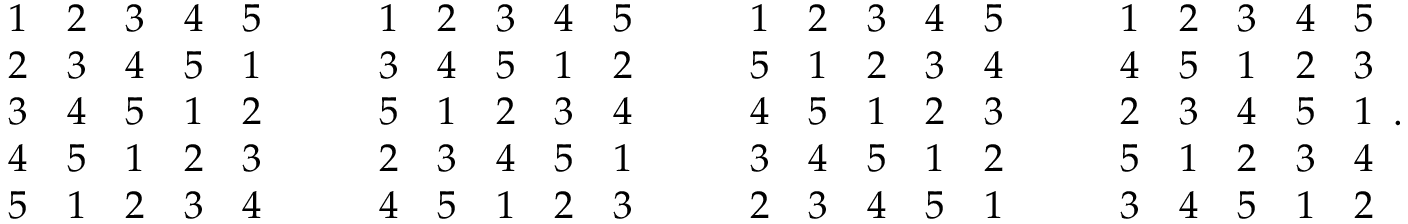<formula> <loc_0><loc_0><loc_500><loc_500>{ \begin{array} { l l l l l } { 1 } & { 2 } & { 3 } & { 4 } & { 5 } \\ { 2 } & { 3 } & { 4 } & { 5 } & { 1 } \\ { 3 } & { 4 } & { 5 } & { 1 } & { 2 } \\ { 4 } & { 5 } & { 1 } & { 2 } & { 3 } \\ { 5 } & { 1 } & { 2 } & { 3 } & { 4 } \end{array} } \quad { \begin{array} { l l l l l } { 1 } & { 2 } & { 3 } & { 4 } & { 5 } \\ { 3 } & { 4 } & { 5 } & { 1 } & { 2 } \\ { 5 } & { 1 } & { 2 } & { 3 } & { 4 } \\ { 2 } & { 3 } & { 4 } & { 5 } & { 1 } \\ { 4 } & { 5 } & { 1 } & { 2 } & { 3 } \end{array} } \quad { \begin{array} { l l l l l } { 1 } & { 2 } & { 3 } & { 4 } & { 5 } \\ { 5 } & { 1 } & { 2 } & { 3 } & { 4 } \\ { 4 } & { 5 } & { 1 } & { 2 } & { 3 } \\ { 3 } & { 4 } & { 5 } & { 1 } & { 2 } \\ { 2 } & { 3 } & { 4 } & { 5 } & { 1 } \end{array} } \quad { \begin{array} { l l l l l } { 1 } & { 2 } & { 3 } & { 4 } & { 5 } \\ { 4 } & { 5 } & { 1 } & { 2 } & { 3 } \\ { 2 } & { 3 } & { 4 } & { 5 } & { 1 } \\ { 5 } & { 1 } & { 2 } & { 3 } & { 4 } \\ { 3 } & { 4 } & { 5 } & { 1 } & { 2 } \end{array} } .</formula> 